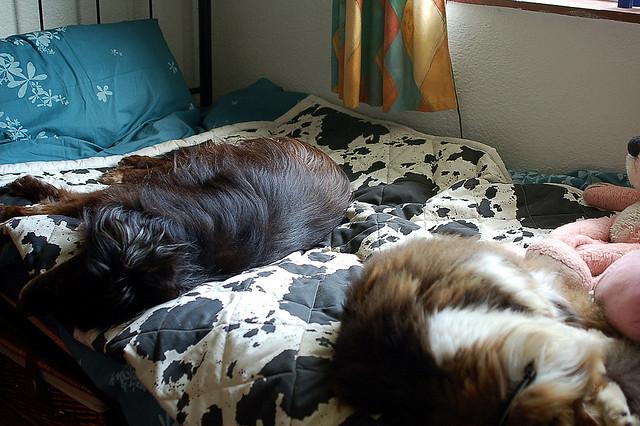What pattern is on the blanket?
Be succinct. Cow print. What piece of furniture are the animals laying on?
Give a very brief answer. Bed. Is the animal sleeping?
Short answer required. Yes. 